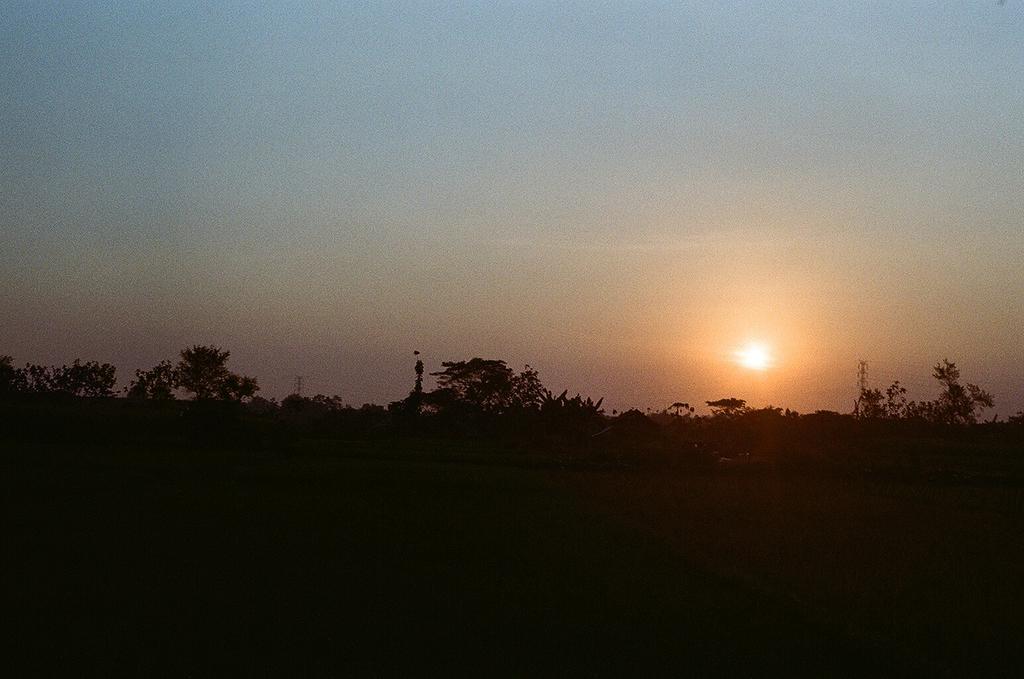Please provide a concise description of this image. At the bottom of the image is dark. In the middle of the image there are trees, sunlight and objects. At the top of the image there is the sky. 